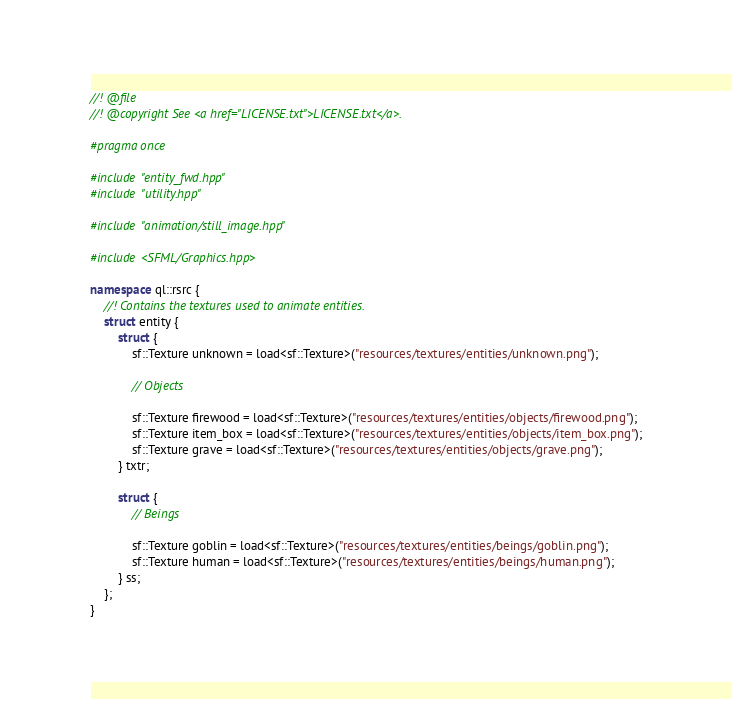Convert code to text. <code><loc_0><loc_0><loc_500><loc_500><_C++_>//! @file
//! @copyright See <a href="LICENSE.txt">LICENSE.txt</a>.

#pragma once

#include "entity_fwd.hpp"
#include "utility.hpp"

#include "animation/still_image.hpp"

#include <SFML/Graphics.hpp>

namespace ql::rsrc {
	//! Contains the textures used to animate entities.
	struct entity {
		struct {
			sf::Texture unknown = load<sf::Texture>("resources/textures/entities/unknown.png");

			// Objects

			sf::Texture firewood = load<sf::Texture>("resources/textures/entities/objects/firewood.png");
			sf::Texture item_box = load<sf::Texture>("resources/textures/entities/objects/item_box.png");
			sf::Texture grave = load<sf::Texture>("resources/textures/entities/objects/grave.png");
		} txtr;

		struct {
			// Beings

			sf::Texture goblin = load<sf::Texture>("resources/textures/entities/beings/goblin.png");
			sf::Texture human = load<sf::Texture>("resources/textures/entities/beings/human.png");
		} ss;
	};
}
</code> 